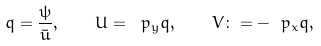Convert formula to latex. <formula><loc_0><loc_0><loc_500><loc_500>q = \frac { \psi } { \bar { u } } , \quad U = \ p _ { y } q , \quad V \colon = - \ p _ { x } q ,</formula> 